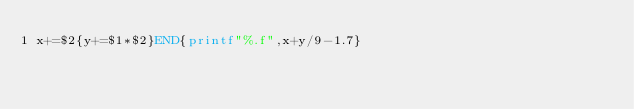Convert code to text. <code><loc_0><loc_0><loc_500><loc_500><_Awk_>x+=$2{y+=$1*$2}END{printf"%.f",x+y/9-1.7}</code> 